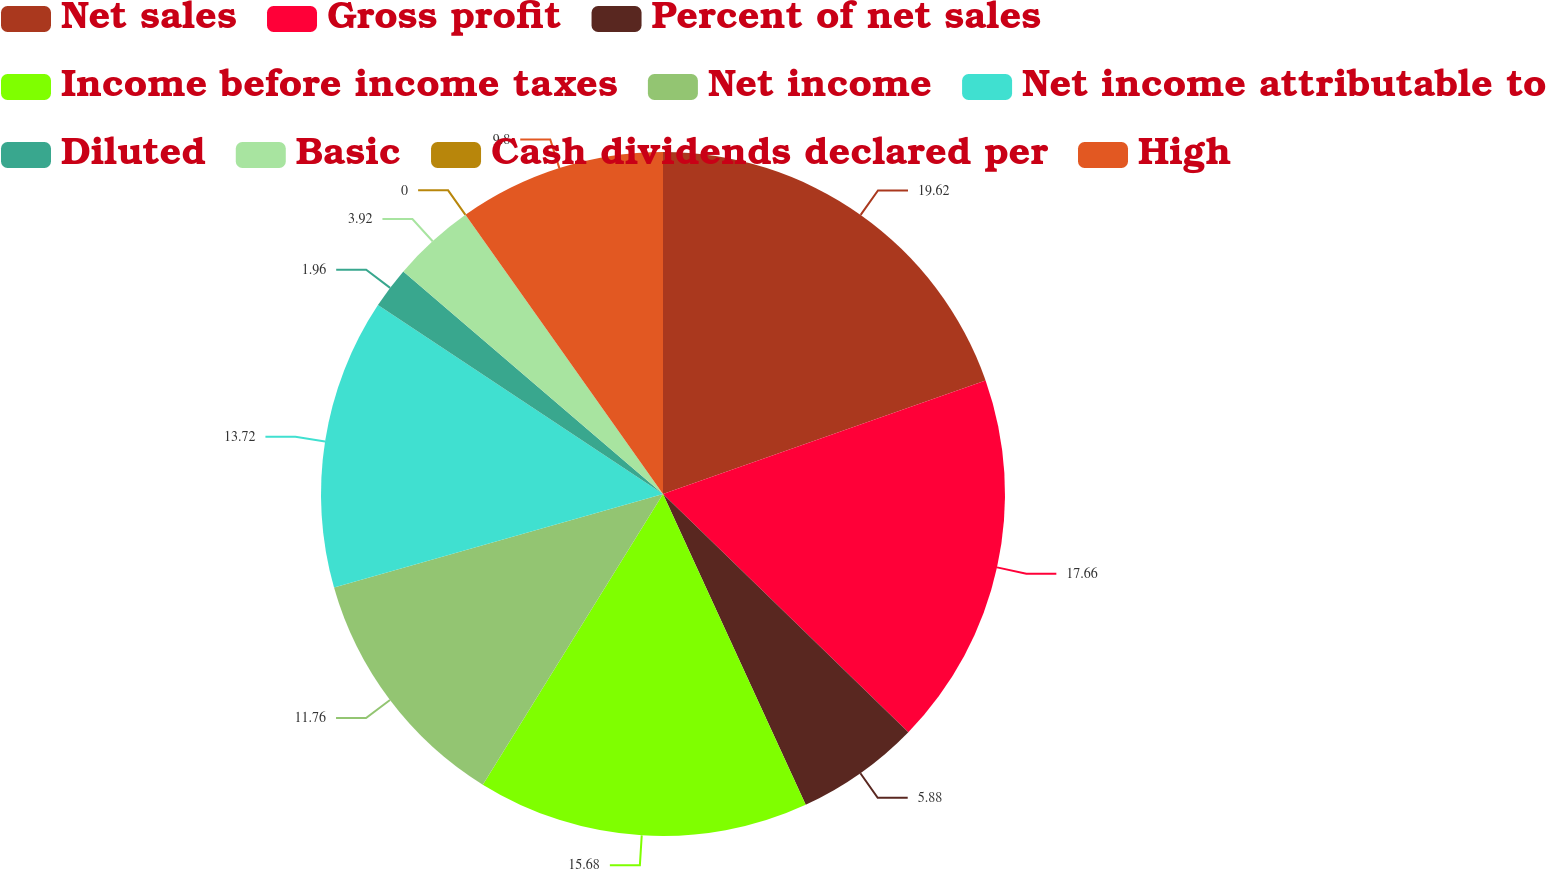<chart> <loc_0><loc_0><loc_500><loc_500><pie_chart><fcel>Net sales<fcel>Gross profit<fcel>Percent of net sales<fcel>Income before income taxes<fcel>Net income<fcel>Net income attributable to<fcel>Diluted<fcel>Basic<fcel>Cash dividends declared per<fcel>High<nl><fcel>19.61%<fcel>17.65%<fcel>5.88%<fcel>15.68%<fcel>11.76%<fcel>13.72%<fcel>1.96%<fcel>3.92%<fcel>0.0%<fcel>9.8%<nl></chart> 